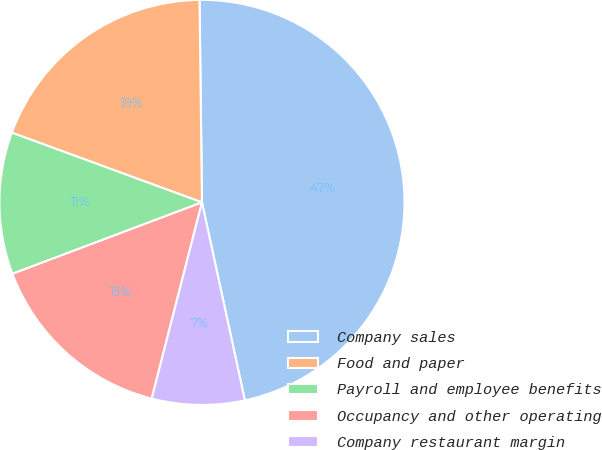<chart> <loc_0><loc_0><loc_500><loc_500><pie_chart><fcel>Company sales<fcel>Food and paper<fcel>Payroll and employee benefits<fcel>Occupancy and other operating<fcel>Company restaurant margin<nl><fcel>46.79%<fcel>19.21%<fcel>11.33%<fcel>15.27%<fcel>7.39%<nl></chart> 